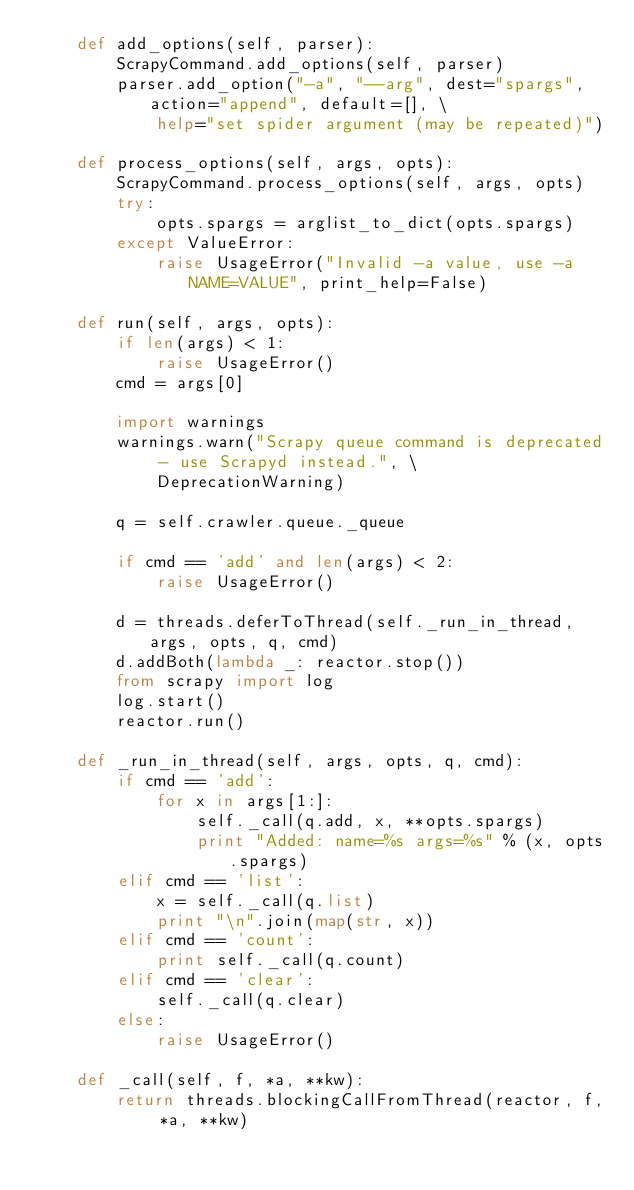<code> <loc_0><loc_0><loc_500><loc_500><_Python_>    def add_options(self, parser):
        ScrapyCommand.add_options(self, parser)
        parser.add_option("-a", "--arg", dest="spargs", action="append", default=[], \
            help="set spider argument (may be repeated)")

    def process_options(self, args, opts):
        ScrapyCommand.process_options(self, args, opts)
        try:
            opts.spargs = arglist_to_dict(opts.spargs)
        except ValueError:
            raise UsageError("Invalid -a value, use -a NAME=VALUE", print_help=False)

    def run(self, args, opts):
        if len(args) < 1:
            raise UsageError()
        cmd = args[0]

        import warnings
        warnings.warn("Scrapy queue command is deprecated - use Scrapyd instead.", \
            DeprecationWarning)

        q = self.crawler.queue._queue

        if cmd == 'add' and len(args) < 2:
            raise UsageError()

        d = threads.deferToThread(self._run_in_thread, args, opts, q, cmd)
        d.addBoth(lambda _: reactor.stop())
        from scrapy import log
        log.start()
        reactor.run()

    def _run_in_thread(self, args, opts, q, cmd):
        if cmd == 'add':
            for x in args[1:]:
                self._call(q.add, x, **opts.spargs)
                print "Added: name=%s args=%s" % (x, opts.spargs)
        elif cmd == 'list':
            x = self._call(q.list)
            print "\n".join(map(str, x))
        elif cmd == 'count':
            print self._call(q.count)
        elif cmd == 'clear':
            self._call(q.clear)
        else:
            raise UsageError()

    def _call(self, f, *a, **kw):
        return threads.blockingCallFromThread(reactor, f, *a, **kw)

</code> 